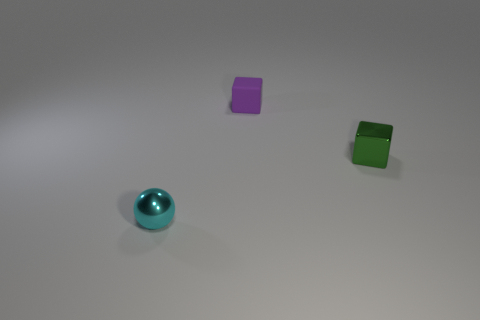Does the metal block have the same size as the thing in front of the green block?
Give a very brief answer. Yes. What size is the thing that is in front of the cube in front of the block left of the green shiny object?
Your answer should be compact. Small. How many balls are to the left of the small matte block?
Keep it short and to the point. 1. What is the material of the small cube left of the tiny cube that is in front of the tiny matte cube?
Keep it short and to the point. Rubber. Are there any other things that are the same size as the rubber cube?
Provide a short and direct response. Yes. Is the size of the rubber cube the same as the sphere?
Your response must be concise. Yes. How many objects are either small metal objects that are behind the small sphere or small things that are right of the purple rubber cube?
Keep it short and to the point. 1. Is the number of cyan things behind the cyan shiny ball greater than the number of green metallic blocks?
Keep it short and to the point. No. What number of other objects are there of the same shape as the cyan shiny object?
Provide a succinct answer. 0. There is a small thing that is in front of the matte block and left of the small green object; what is its material?
Your response must be concise. Metal. 